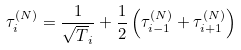Convert formula to latex. <formula><loc_0><loc_0><loc_500><loc_500>\tau ^ { ( N ) } _ { i } = \frac { 1 } { \sqrt { T } _ { i } } + \frac { 1 } { 2 } \left ( \tau ^ { ( N ) } _ { i - 1 } + \tau ^ { ( N ) } _ { i + 1 } \right )</formula> 